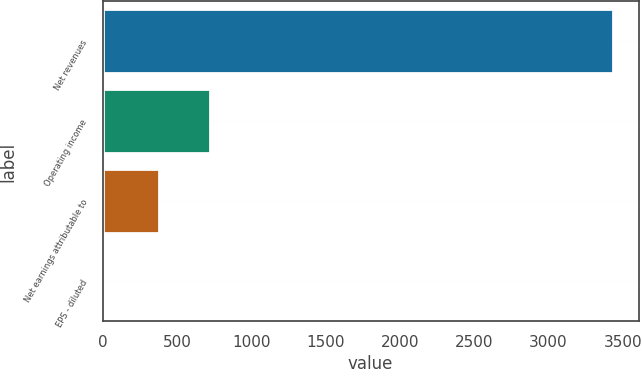Convert chart. <chart><loc_0><loc_0><loc_500><loc_500><bar_chart><fcel>Net revenues<fcel>Operating income<fcel>Net earnings attributable to<fcel>EPS - diluted<nl><fcel>3435.9<fcel>725.64<fcel>382.1<fcel>0.5<nl></chart> 